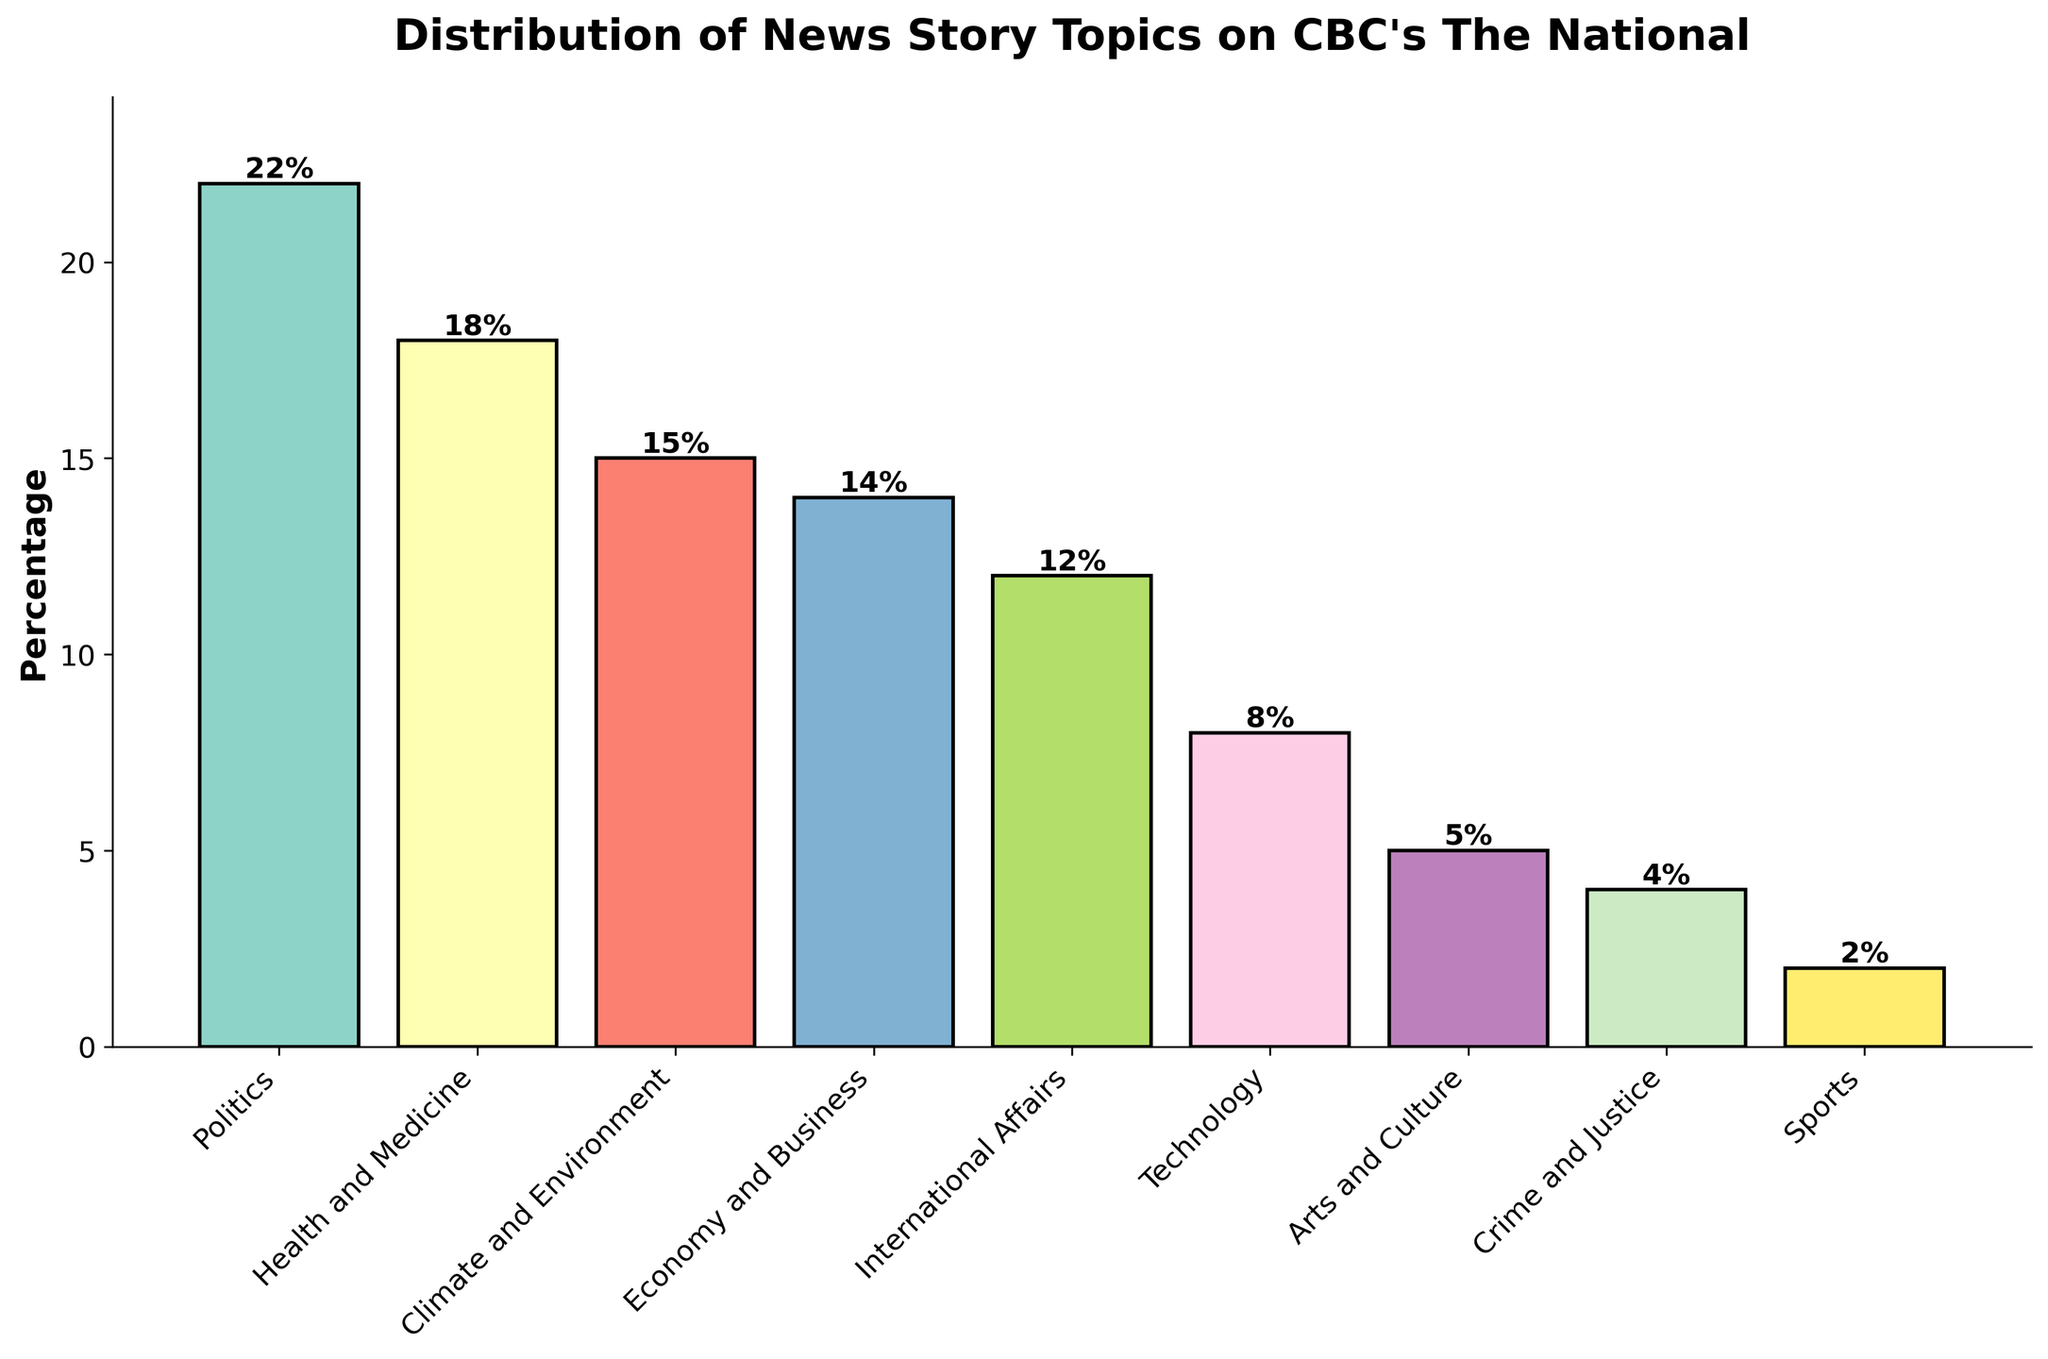What's the most common news story topic on CBC's The National? The bar representing Politics has the highest percentage, at 22%.
Answer: Politics Which topic has a higher percentage: Health and Medicine or Technology? The bar for Health and Medicine shows 18%, while the bar for Technology shows 8%. Thus, Health and Medicine has a higher percentage than Technology.
Answer: Health and Medicine What's the sum of the percentages for Sports, Arts and Culture, and Crime and Justice? The percentages for Sports, Arts and Culture, and Crime and Justice are 2%, 5%, and 4%, respectively. Adding these together: 2 + 5 + 4 = 11.
Answer: 11% How many percentage points higher is Politics compared to Economy and Business? The bar for Politics shows 22%, and for Economy and Business, it shows 14%. The difference is 22 - 14 = 8 percentage points.
Answer: 8 percentage points What is the combined percentage of Climate and Environment and International Affairs? The bar for Climate and Environment shows 15%, and for International Affairs, it shows 12%. Adding these together: 15 + 12 = 27.
Answer: 27% Are there more stories focused on International Affairs or Economy and Business? The bar for International Affairs shows 12%, while the bar for Economy and Business shows 14%. Thus, there are more stories focused on Economy and Business.
Answer: Economy and Business Which topic has the shortest bar height, and what is its percentage? The bar for Sports has the shortest height, showing 2%.
Answer: Sports, 2% What's the difference between the percentages of the top two topics? The top two topics are Politics (22%) and Health and Medicine (18%). The difference is 22 - 18 = 4 percentage points.
Answer: 4 percentage points How many topics have a percentage greater than 10%? The topics with percentages greater than 10% are: Politics (22%), Health and Medicine (18%), Climate and Environment (15%), Economy and Business (14%), and International Affairs (12%). There are 5 such topics.
Answer: 5 What is the average percentage of the bottom three topics? The percentages for the bottom three topics are Sports (2%), Arts and Culture (5%), and Crime and Justice (4%). Adding these together and dividing by 3 gives (2 + 5 + 4) / 3 = 3.67%.
Answer: 3.67% 